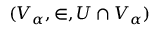Convert formula to latex. <formula><loc_0><loc_0><loc_500><loc_500>( V _ { \alpha } , \in , U \cap V _ { \alpha } )</formula> 